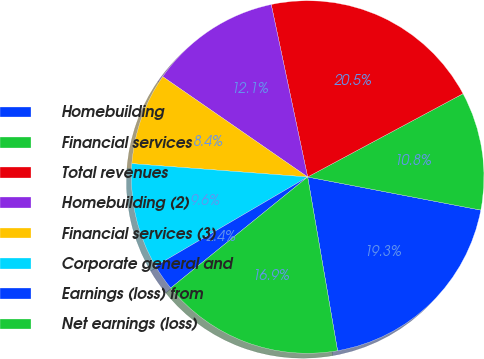Convert chart. <chart><loc_0><loc_0><loc_500><loc_500><pie_chart><fcel>Homebuilding<fcel>Financial services<fcel>Total revenues<fcel>Homebuilding (2)<fcel>Financial services (3)<fcel>Corporate general and<fcel>Earnings (loss) from<fcel>Net earnings (loss)<nl><fcel>19.28%<fcel>10.84%<fcel>20.48%<fcel>12.05%<fcel>8.43%<fcel>9.64%<fcel>2.41%<fcel>16.87%<nl></chart> 